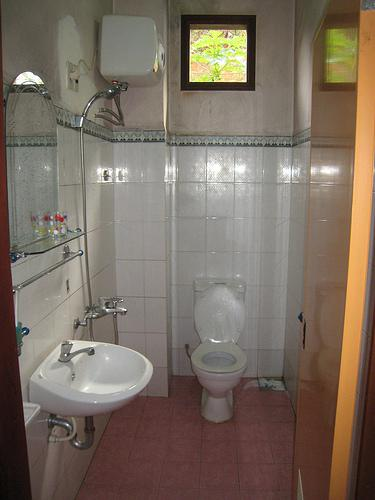Question: what is the room?
Choices:
A. Bedroom.
B. The bathroom.
C. Kitchen.
D. Dining Room.
Answer with the letter. Answer: B Question: what color is the sink?
Choices:
A. Black.
B. White.
C. Silver.
D. Red.
Answer with the letter. Answer: B Question: where is the toilet?
Choices:
A. In the back.
B. The bathroom.
C. Near the sink.
D. Beside the shower.
Answer with the letter. Answer: A Question: what is the sink made of?
Choices:
A. Porcelain.
B. Glass.
C. Stainless steel.
D. Ceramic.
Answer with the letter. Answer: A 